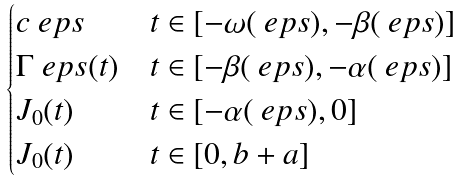Convert formula to latex. <formula><loc_0><loc_0><loc_500><loc_500>\begin{cases} c _ { \ } e p s & t \in [ - \omega ( \ e p s ) , - \beta ( \ e p s ) ] \\ \Gamma _ { \ } e p s ( t ) & t \in [ - \beta ( \ e p s ) , - \alpha ( \ e p s ) ] \\ J _ { 0 } ( t ) & t \in [ - \alpha ( \ e p s ) , 0 ] \\ J _ { 0 } ( t ) & t \in [ 0 , b + a ] \end{cases}</formula> 